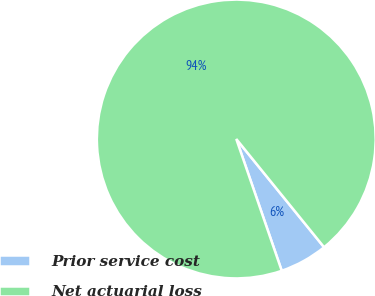Convert chart. <chart><loc_0><loc_0><loc_500><loc_500><pie_chart><fcel>Prior service cost<fcel>Net actuarial loss<nl><fcel>5.56%<fcel>94.44%<nl></chart> 